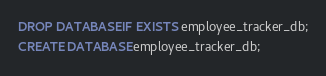<code> <loc_0><loc_0><loc_500><loc_500><_SQL_>
DROP DATABASE IF EXISTS employee_tracker_db;
CREATE DATABASE employee_tracker_db;</code> 